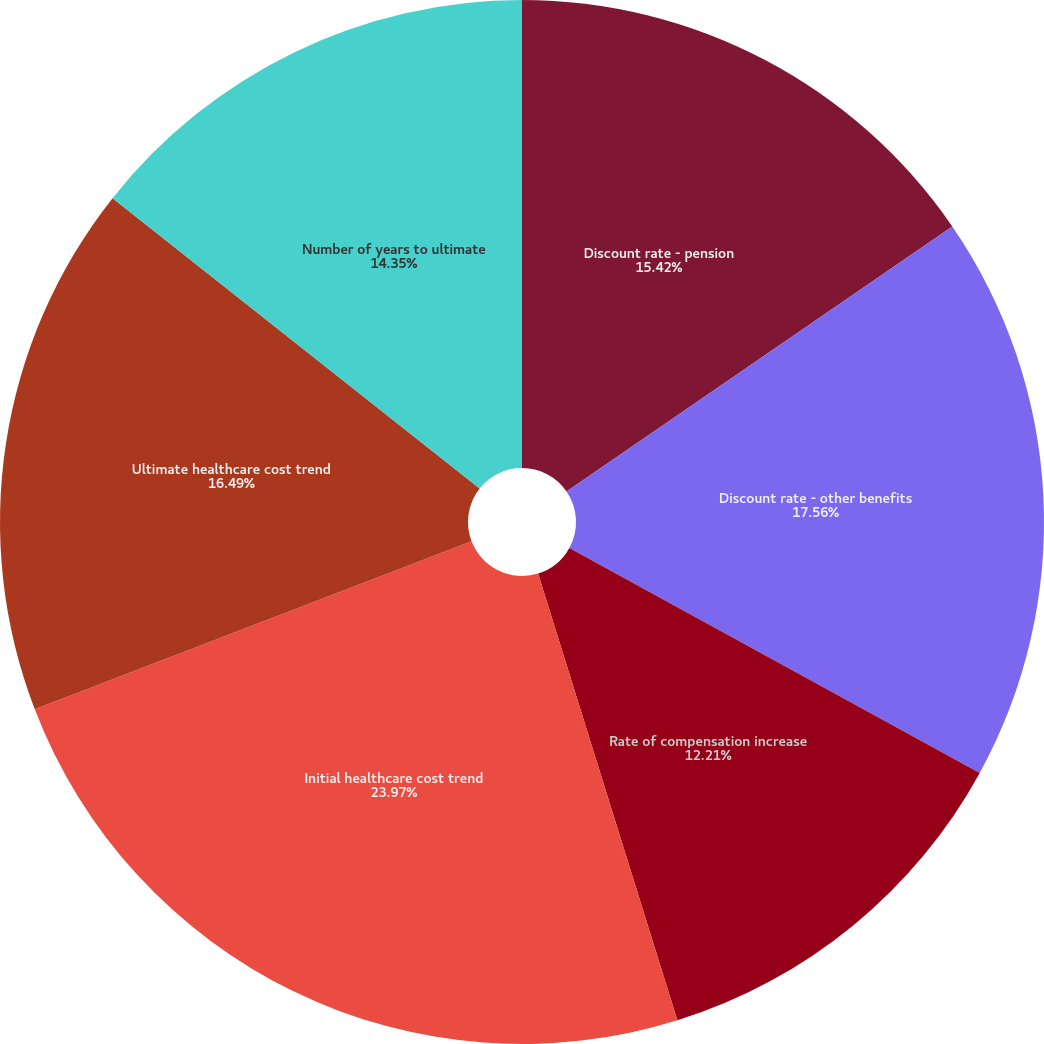Convert chart to OTSL. <chart><loc_0><loc_0><loc_500><loc_500><pie_chart><fcel>Discount rate - pension<fcel>Discount rate - other benefits<fcel>Rate of compensation increase<fcel>Initial healthcare cost trend<fcel>Ultimate healthcare cost trend<fcel>Number of years to ultimate<nl><fcel>15.42%<fcel>17.56%<fcel>12.21%<fcel>23.97%<fcel>16.49%<fcel>14.35%<nl></chart> 